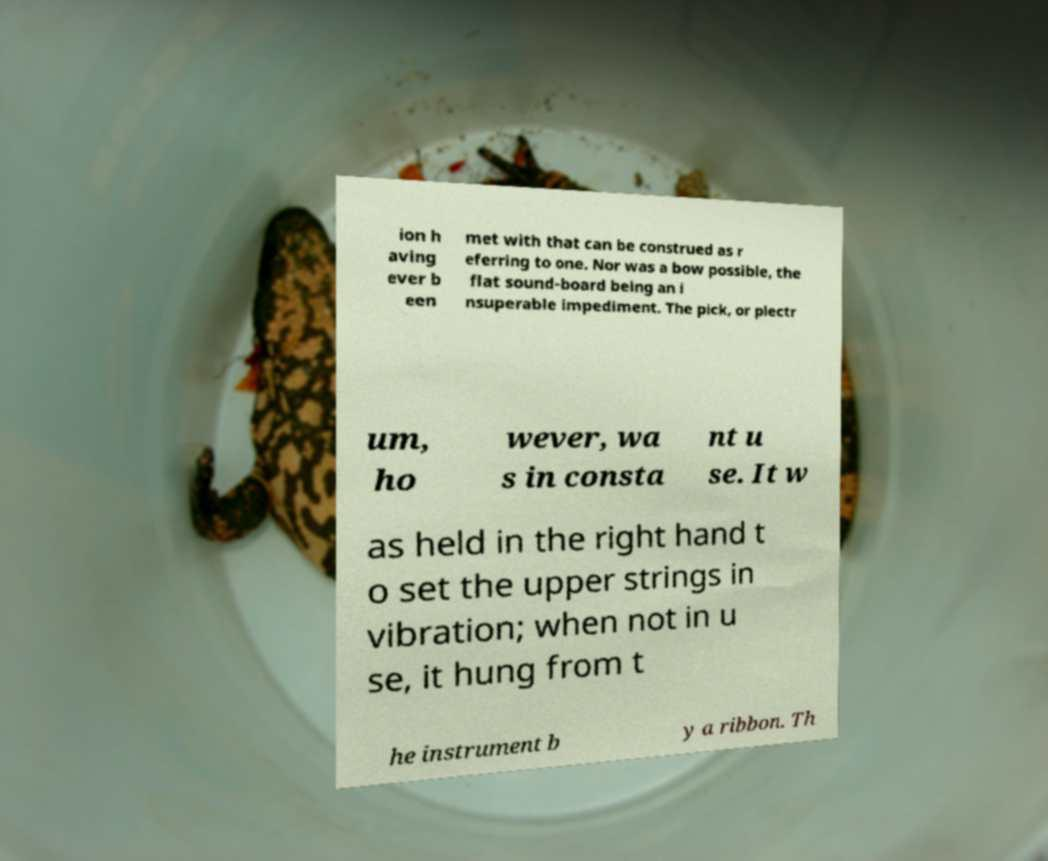Please read and relay the text visible in this image. What does it say? ion h aving ever b een met with that can be construed as r eferring to one. Nor was a bow possible, the flat sound-board being an i nsuperable impediment. The pick, or plectr um, ho wever, wa s in consta nt u se. It w as held in the right hand t o set the upper strings in vibration; when not in u se, it hung from t he instrument b y a ribbon. Th 